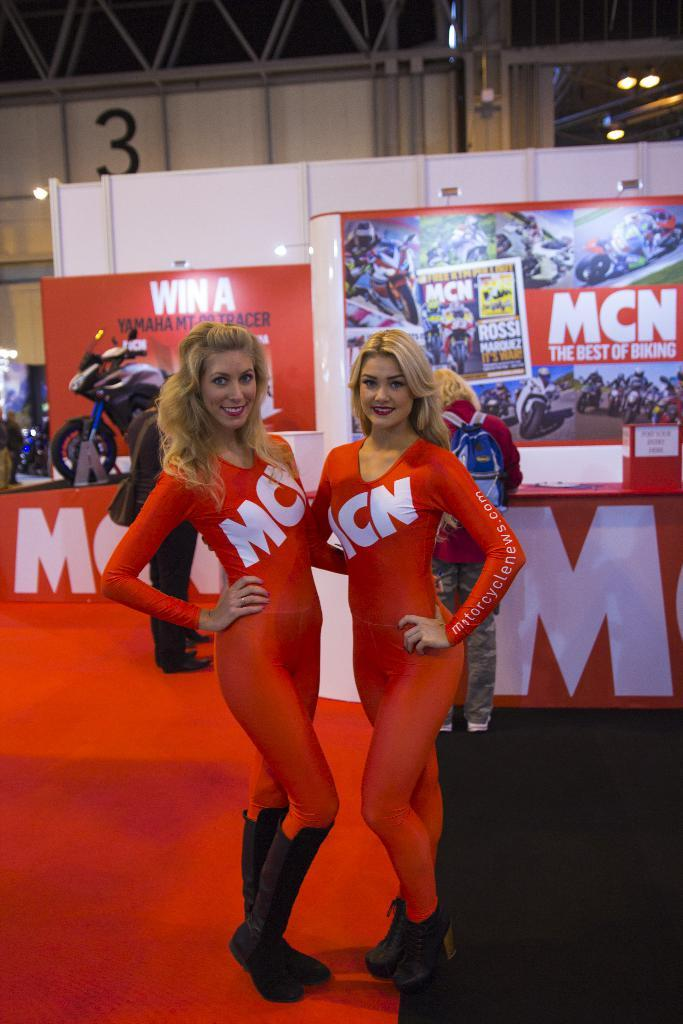Provide a one-sentence caption for the provided image. MCN is shown as an advert on these two model's outfits. 